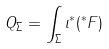Convert formula to latex. <formula><loc_0><loc_0><loc_500><loc_500>Q _ { \Sigma } = \int _ { \Sigma } \iota ^ { * } ( ^ { * } F )</formula> 